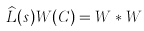<formula> <loc_0><loc_0><loc_500><loc_500>\widehat { L } ( s ) W ( C ) = W \ast W</formula> 